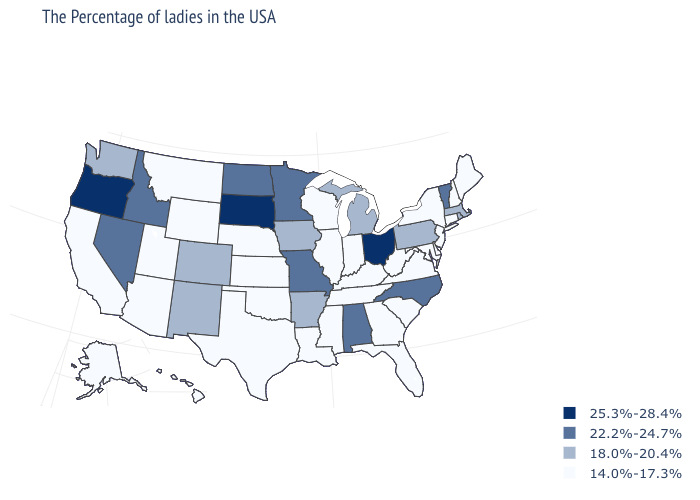Name the states that have a value in the range 18.0%-20.4%?
Keep it brief. Massachusetts, Rhode Island, Pennsylvania, Michigan, Arkansas, Iowa, Colorado, New Mexico, Washington. Name the states that have a value in the range 22.2%-24.7%?
Concise answer only. Vermont, North Carolina, Alabama, Missouri, Minnesota, North Dakota, Idaho, Nevada. Does the first symbol in the legend represent the smallest category?
Write a very short answer. No. What is the highest value in the USA?
Concise answer only. 25.3%-28.4%. What is the highest value in the USA?
Short answer required. 25.3%-28.4%. Name the states that have a value in the range 22.2%-24.7%?
Be succinct. Vermont, North Carolina, Alabama, Missouri, Minnesota, North Dakota, Idaho, Nevada. What is the value of South Dakota?
Give a very brief answer. 25.3%-28.4%. What is the value of West Virginia?
Quick response, please. 14.0%-17.3%. Name the states that have a value in the range 18.0%-20.4%?
Short answer required. Massachusetts, Rhode Island, Pennsylvania, Michigan, Arkansas, Iowa, Colorado, New Mexico, Washington. Does Oregon have the highest value in the USA?
Concise answer only. Yes. What is the highest value in the USA?
Write a very short answer. 25.3%-28.4%. What is the value of Wyoming?
Be succinct. 14.0%-17.3%. Which states have the lowest value in the USA?
Concise answer only. Maine, New Hampshire, Connecticut, New York, New Jersey, Delaware, Maryland, Virginia, South Carolina, West Virginia, Florida, Georgia, Kentucky, Indiana, Tennessee, Wisconsin, Illinois, Mississippi, Louisiana, Kansas, Nebraska, Oklahoma, Texas, Wyoming, Utah, Montana, Arizona, California, Alaska, Hawaii. What is the highest value in the West ?
Quick response, please. 25.3%-28.4%. What is the highest value in the MidWest ?
Give a very brief answer. 25.3%-28.4%. 